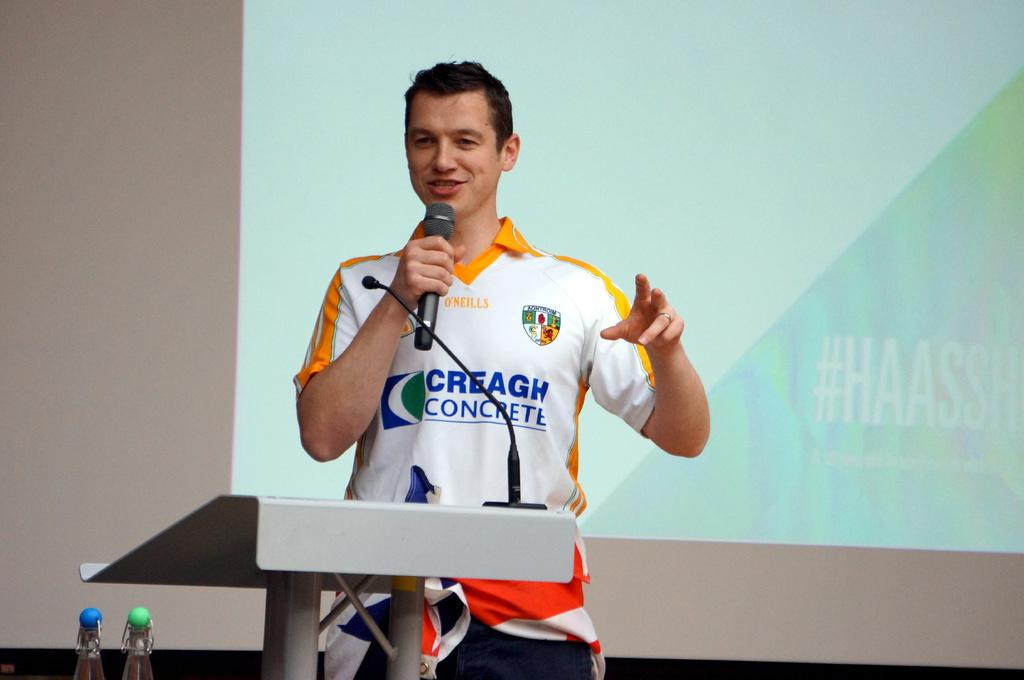<image>
Create a compact narrative representing the image presented. a man that is wearing a concrete shirt in front of a projected image 